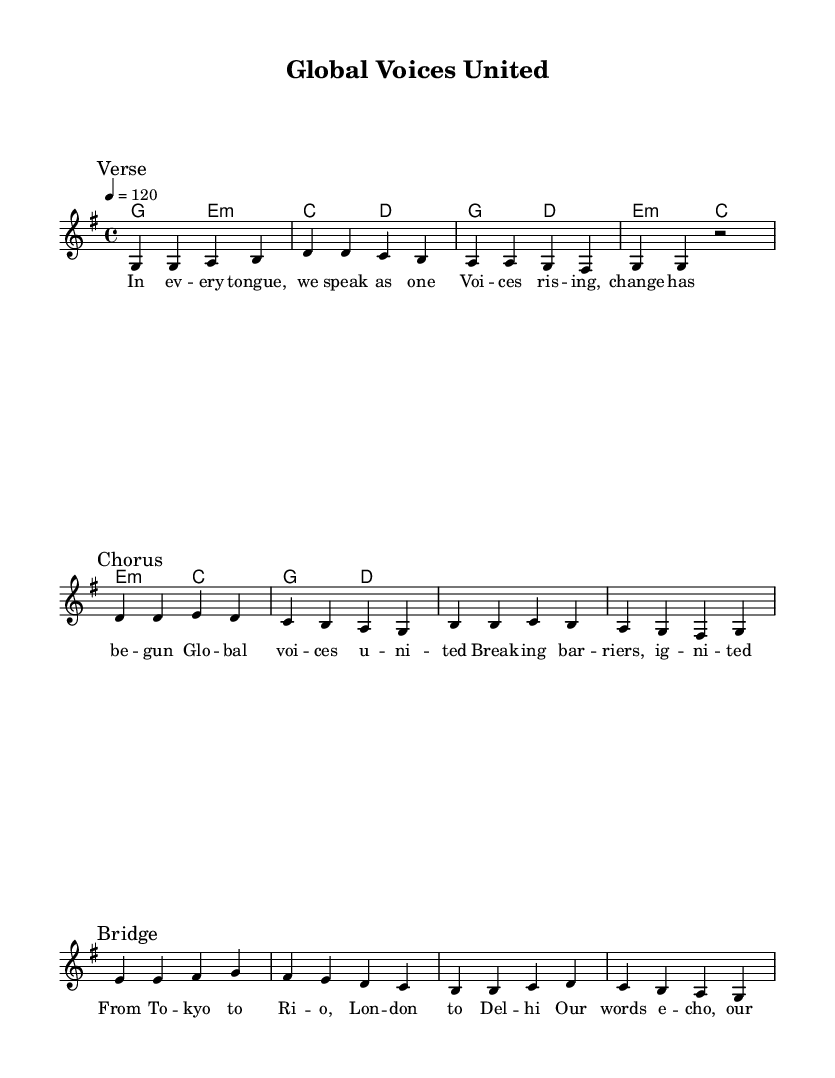What is the key signature of this music? The key signature is G major, which has one sharp (F#). This can be identified in the global section of the code where `\key g \major` is specified.
Answer: G major What is the time signature of this music? The time signature is 4/4, indicated in the global section of the code with `\time 4/4`. This means there are four beats per measure, and the quarter note gets one beat.
Answer: 4/4 What is the tempo marking of this music? The tempo marking is 120 beats per minute, shown as `\tempo 4 = 120` in the global section. This indicates how fast the music should be played.
Answer: 120 What is the structure of the song based on the given sections? The structure consists of three distinct sections – Verse, Chorus, and Bridge. Each section is clearly marked in the melody part with `\mark` statements, indicating the arrangement of the song.
Answer: Verse, Chorus, Bridge Which chord is played in the first measure? The chord in the first measure is G major, represented as `g2` in the harmonies section. This identifies the first harmonic foundation of the piece.
Answer: G major What social movement theme is hinted at in the lyrics? The theme of unity and global connection is hinted at in the lyrics. Phrases like "Global voices united" suggest a focus on collective action and understanding across different cultures.
Answer: Unity 